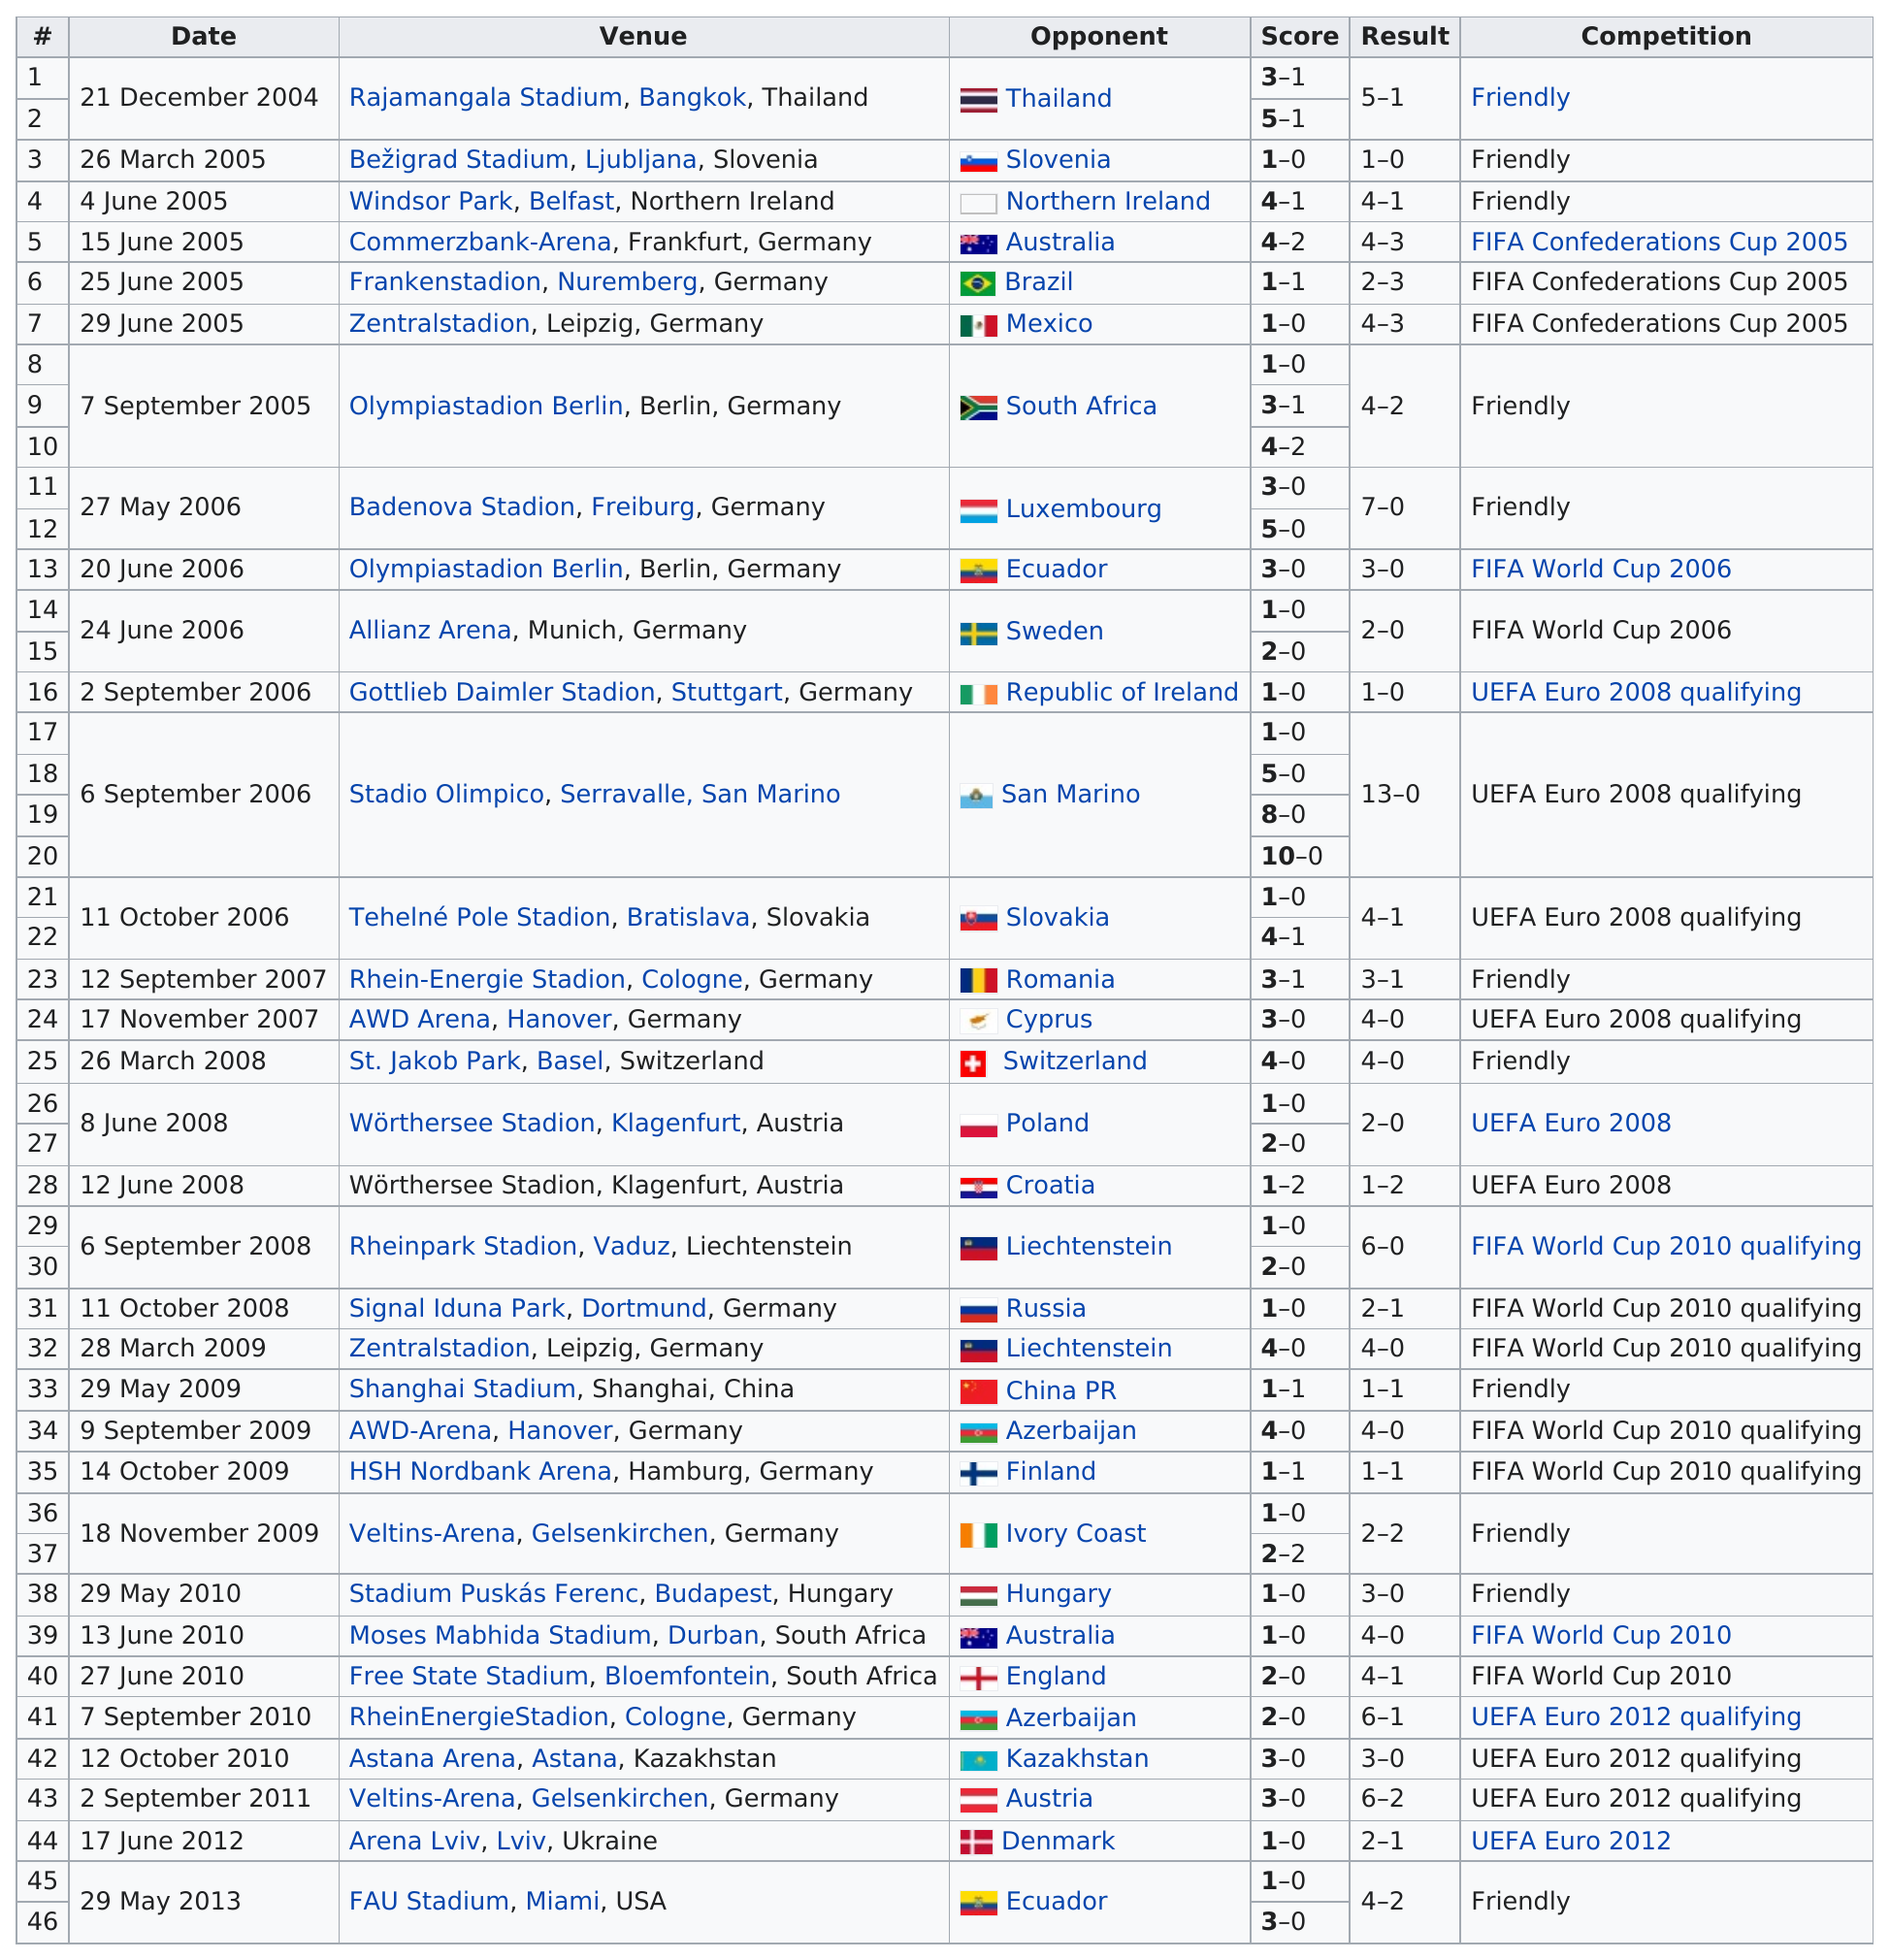Specify some key components in this picture. The first "friendly" competition was held at Rajamangala Stadium in Bangkok, Thailand. The Zentralstadion in Leipzig, Germany was used as the venue next after June 25, 2005. Podolski, the international soccer player, holds the record for the highest number of goals scored in a single game with 10. The most games were held in Germany. The total number of goals that were scored against Romania in 2007 was 3. 